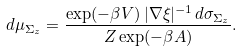<formula> <loc_0><loc_0><loc_500><loc_500>d \mu _ { \Sigma _ { z } } = \frac { \exp ( - \beta V ) \, | \nabla \xi | ^ { - 1 } \, d \sigma _ { \Sigma _ { z } } } { Z \exp ( - \beta A ) } .</formula> 